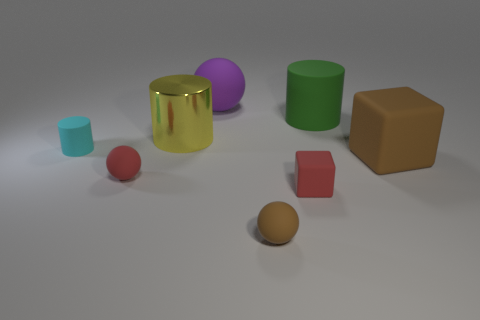Are there more brown matte things that are in front of the big yellow metallic thing than large red matte objects?
Offer a very short reply. Yes. Do the tiny cyan rubber thing and the large shiny object to the left of the large green rubber object have the same shape?
Make the answer very short. Yes. How many cubes are the same size as the cyan matte cylinder?
Keep it short and to the point. 1. What number of small rubber objects are to the right of the small brown ball that is on the right side of the small red matte thing on the left side of the yellow metal object?
Provide a short and direct response. 1. Is the number of large objects in front of the large purple rubber ball the same as the number of rubber balls on the left side of the green object?
Make the answer very short. Yes. How many big brown matte objects are the same shape as the tiny brown matte thing?
Provide a succinct answer. 0. Are there any red spheres made of the same material as the cyan cylinder?
Offer a very short reply. Yes. There is a tiny matte thing that is the same color as the small matte cube; what is its shape?
Offer a terse response. Sphere. How many purple matte cylinders are there?
Make the answer very short. 0. What number of cylinders are purple things or large objects?
Provide a succinct answer. 2. 